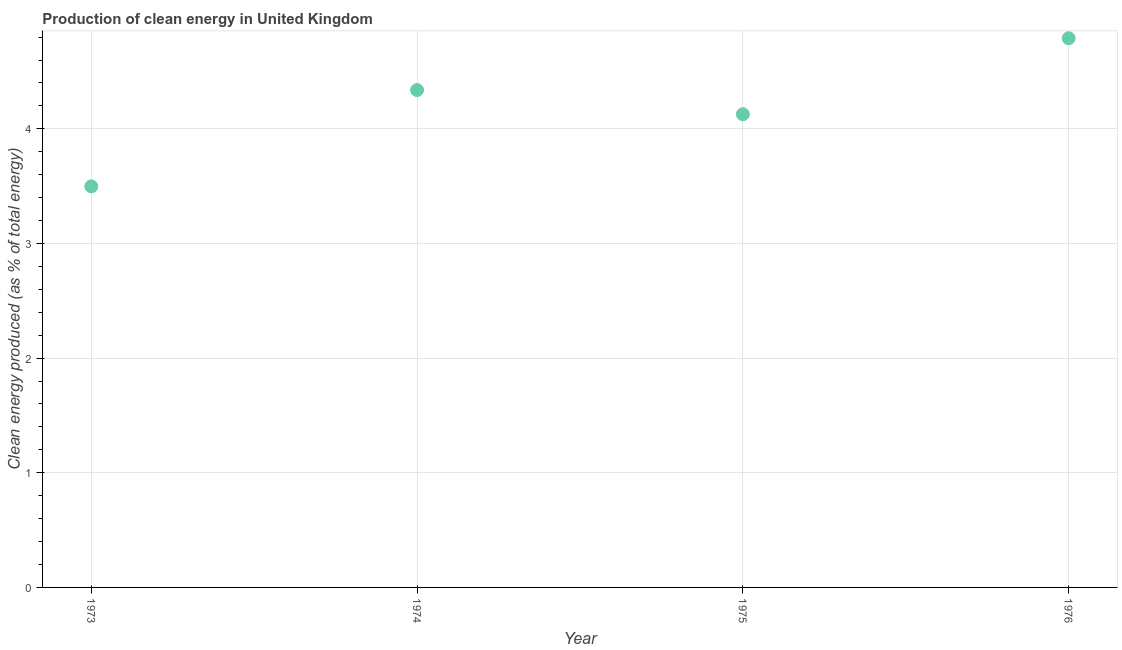What is the production of clean energy in 1975?
Keep it short and to the point. 4.13. Across all years, what is the maximum production of clean energy?
Offer a terse response. 4.79. Across all years, what is the minimum production of clean energy?
Your response must be concise. 3.5. In which year was the production of clean energy maximum?
Your answer should be compact. 1976. What is the sum of the production of clean energy?
Keep it short and to the point. 16.75. What is the difference between the production of clean energy in 1973 and 1976?
Offer a very short reply. -1.29. What is the average production of clean energy per year?
Offer a very short reply. 4.19. What is the median production of clean energy?
Keep it short and to the point. 4.23. Do a majority of the years between 1975 and 1973 (inclusive) have production of clean energy greater than 2.2 %?
Ensure brevity in your answer.  No. What is the ratio of the production of clean energy in 1973 to that in 1976?
Provide a short and direct response. 0.73. Is the difference between the production of clean energy in 1973 and 1976 greater than the difference between any two years?
Your answer should be compact. Yes. What is the difference between the highest and the second highest production of clean energy?
Your answer should be compact. 0.45. What is the difference between the highest and the lowest production of clean energy?
Your answer should be very brief. 1.29. Does the production of clean energy monotonically increase over the years?
Your response must be concise. No. How many dotlines are there?
Provide a succinct answer. 1. Are the values on the major ticks of Y-axis written in scientific E-notation?
Provide a short and direct response. No. Does the graph contain grids?
Your response must be concise. Yes. What is the title of the graph?
Your answer should be very brief. Production of clean energy in United Kingdom. What is the label or title of the X-axis?
Offer a terse response. Year. What is the label or title of the Y-axis?
Ensure brevity in your answer.  Clean energy produced (as % of total energy). What is the Clean energy produced (as % of total energy) in 1973?
Keep it short and to the point. 3.5. What is the Clean energy produced (as % of total energy) in 1974?
Keep it short and to the point. 4.34. What is the Clean energy produced (as % of total energy) in 1975?
Provide a succinct answer. 4.13. What is the Clean energy produced (as % of total energy) in 1976?
Provide a succinct answer. 4.79. What is the difference between the Clean energy produced (as % of total energy) in 1973 and 1974?
Give a very brief answer. -0.84. What is the difference between the Clean energy produced (as % of total energy) in 1973 and 1975?
Keep it short and to the point. -0.63. What is the difference between the Clean energy produced (as % of total energy) in 1973 and 1976?
Keep it short and to the point. -1.29. What is the difference between the Clean energy produced (as % of total energy) in 1974 and 1975?
Offer a very short reply. 0.21. What is the difference between the Clean energy produced (as % of total energy) in 1974 and 1976?
Provide a short and direct response. -0.45. What is the difference between the Clean energy produced (as % of total energy) in 1975 and 1976?
Ensure brevity in your answer.  -0.66. What is the ratio of the Clean energy produced (as % of total energy) in 1973 to that in 1974?
Your response must be concise. 0.81. What is the ratio of the Clean energy produced (as % of total energy) in 1973 to that in 1975?
Offer a very short reply. 0.85. What is the ratio of the Clean energy produced (as % of total energy) in 1973 to that in 1976?
Your answer should be compact. 0.73. What is the ratio of the Clean energy produced (as % of total energy) in 1974 to that in 1975?
Your answer should be compact. 1.05. What is the ratio of the Clean energy produced (as % of total energy) in 1974 to that in 1976?
Keep it short and to the point. 0.91. What is the ratio of the Clean energy produced (as % of total energy) in 1975 to that in 1976?
Make the answer very short. 0.86. 